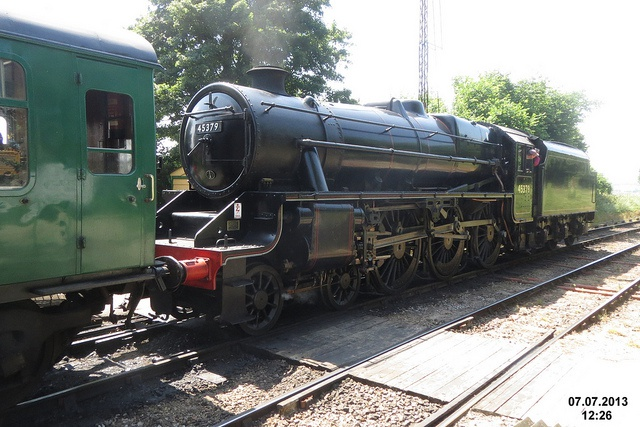Describe the objects in this image and their specific colors. I can see train in white, black, gray, and darkblue tones, people in white, gray, and black tones, and people in white, brown, gray, purple, and darkgray tones in this image. 